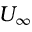<formula> <loc_0><loc_0><loc_500><loc_500>U _ { \infty }</formula> 